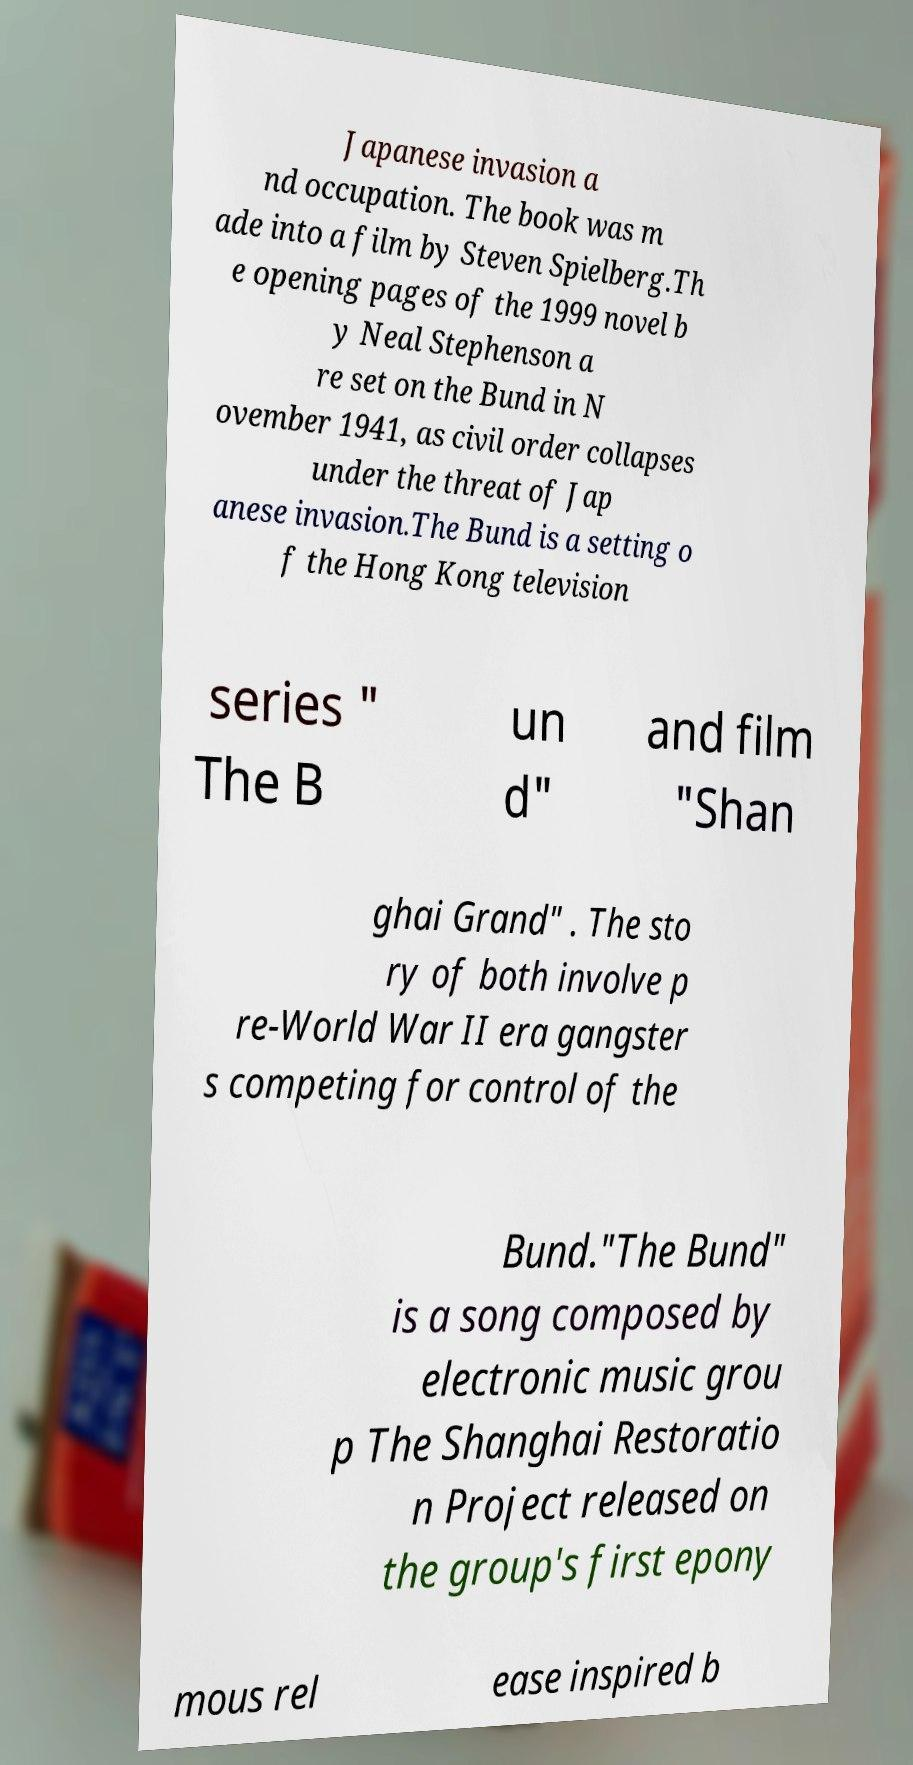I need the written content from this picture converted into text. Can you do that? Japanese invasion a nd occupation. The book was m ade into a film by Steven Spielberg.Th e opening pages of the 1999 novel b y Neal Stephenson a re set on the Bund in N ovember 1941, as civil order collapses under the threat of Jap anese invasion.The Bund is a setting o f the Hong Kong television series " The B un d" and film "Shan ghai Grand" . The sto ry of both involve p re-World War II era gangster s competing for control of the Bund."The Bund" is a song composed by electronic music grou p The Shanghai Restoratio n Project released on the group's first epony mous rel ease inspired b 